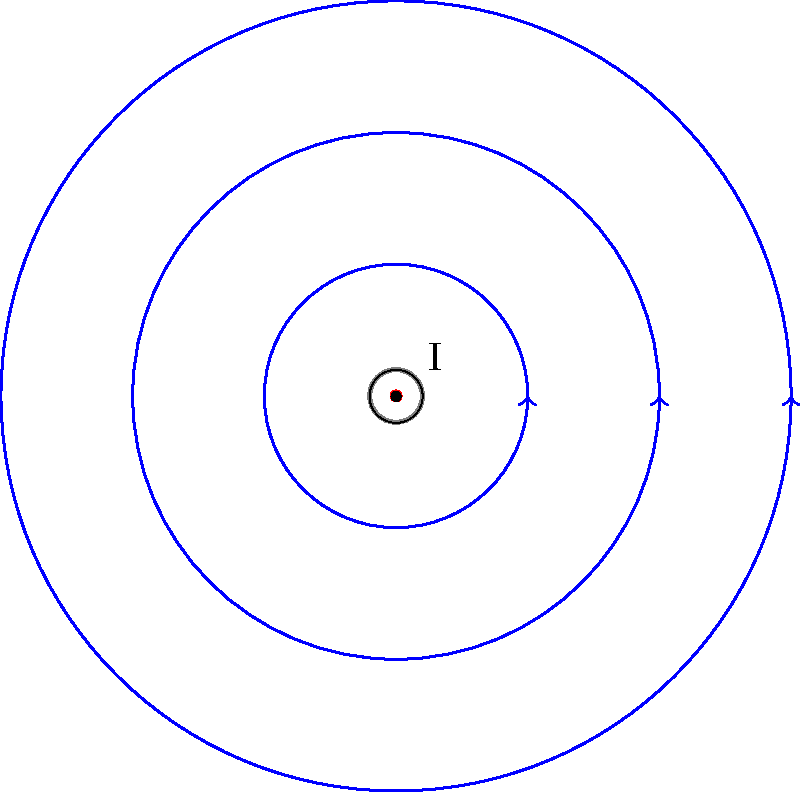Hey tech-savvy teen! Imagine you're reading about electromagnetics on your favorite e-book platform. You come across this diagram showing magnetic field lines around a current-carrying wire. If the current (I) is flowing out of the page, in which direction do the magnetic field lines point? Let's break this down step-by-step:

1. First, we need to understand the right-hand rule for current-carrying wires. This rule helps us determine the direction of the magnetic field around a current-carrying wire.

2. The right-hand rule states: If you grab the wire with your right hand, with your thumb pointing in the direction of the current, your fingers will curl in the direction of the magnetic field lines.

3. In this case, we're told that the current (I) is flowing out of the page. This is represented by the dot (⊙) in the center of the diagram.

4. To visualize this, imagine sticking your right thumb out of the page, just like the current.

5. Now, if you curl your fingers, they will wrap around the wire in a clockwise direction when viewed from above.

6. Looking at the diagram, we can see that the arrows on the circular field lines are indeed pointing clockwise.

Therefore, the magnetic field lines point in a clockwise direction around the wire when the current is flowing out of the page.
Answer: Clockwise 